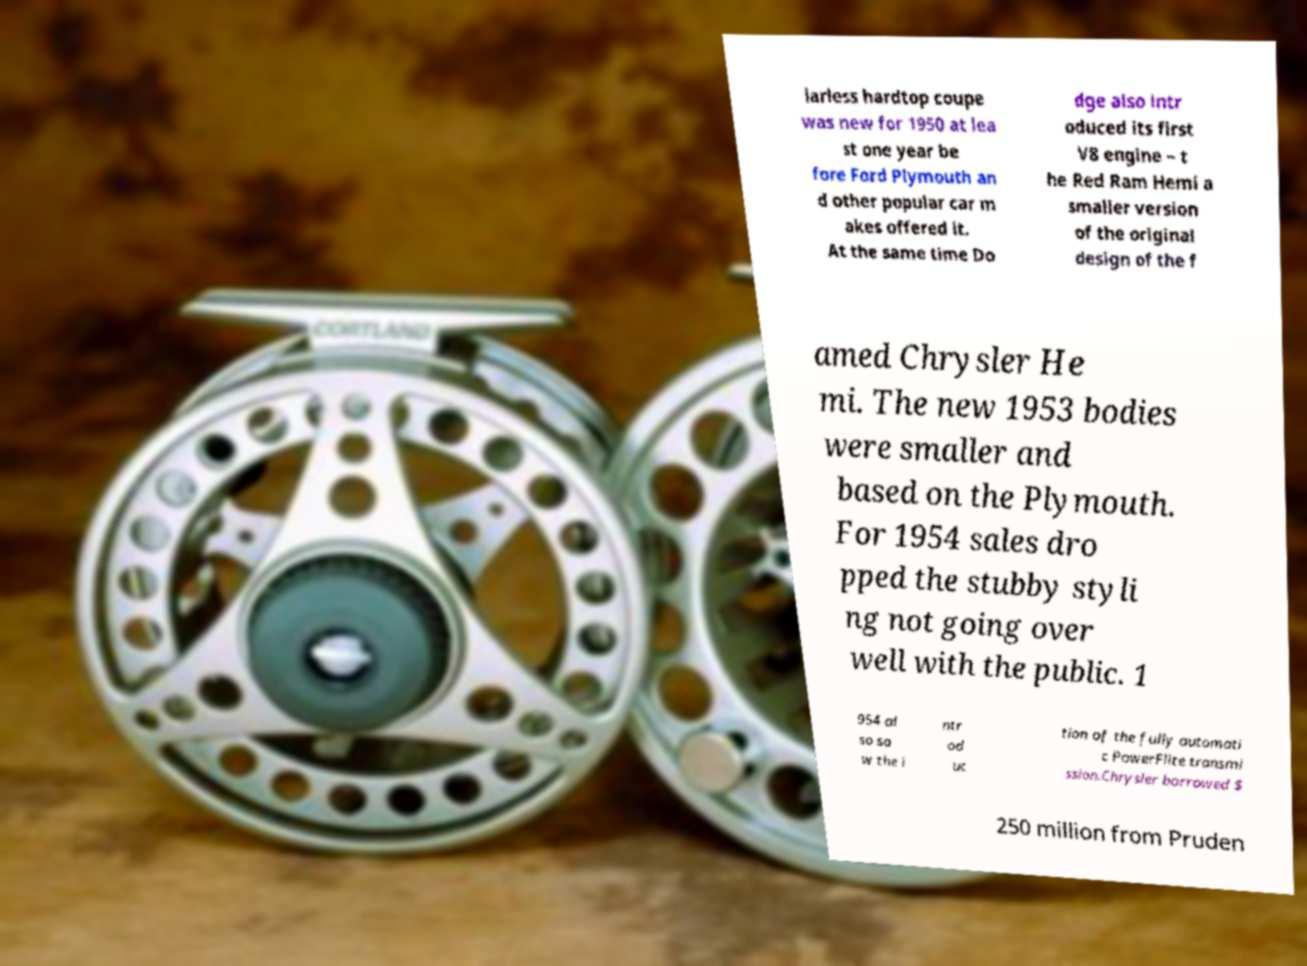There's text embedded in this image that I need extracted. Can you transcribe it verbatim? larless hardtop coupe was new for 1950 at lea st one year be fore Ford Plymouth an d other popular car m akes offered it. At the same time Do dge also intr oduced its first V8 engine – t he Red Ram Hemi a smaller version of the original design of the f amed Chrysler He mi. The new 1953 bodies were smaller and based on the Plymouth. For 1954 sales dro pped the stubby styli ng not going over well with the public. 1 954 al so sa w the i ntr od uc tion of the fully automati c PowerFlite transmi ssion.Chrysler borrowed $ 250 million from Pruden 